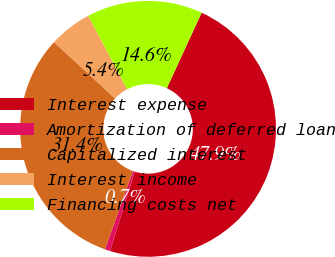Convert chart. <chart><loc_0><loc_0><loc_500><loc_500><pie_chart><fcel>Interest expense<fcel>Amortization of deferred loan<fcel>Capitalized interest<fcel>Interest income<fcel>Financing costs net<nl><fcel>47.93%<fcel>0.67%<fcel>31.39%<fcel>5.4%<fcel>14.61%<nl></chart> 